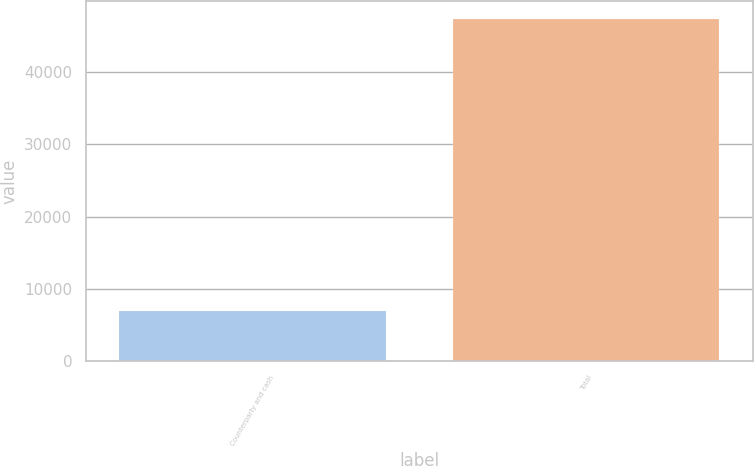Convert chart to OTSL. <chart><loc_0><loc_0><loc_500><loc_500><bar_chart><fcel>Counterparty and cash<fcel>Total<nl><fcel>7016<fcel>47376<nl></chart> 